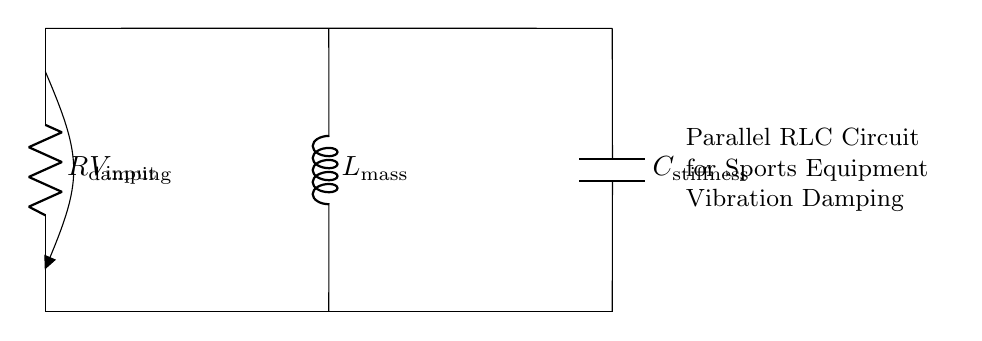What is the type of this circuit? This circuit is identified as a parallel RLC circuit due to its arrangement of a resistor, an inductor, and a capacitor connected in parallel configuration.
Answer: parallel RLC circuit What components are present in the circuit? The components present in the circuit are a resistor, an inductor, and a capacitor. This can be identified from the labels R, L, and C in the circuit diagram.
Answer: resistor, inductor, capacitor What is the purpose of the resistor in this circuit? The purpose of the resistor in this circuit is to provide damping. This is indicated by its label R_damping, which suggests it's specifically meant to reduce oscillations caused by the inductor and capacitor.
Answer: damping What is the role of the capacitor in this setup? The role of the capacitor in this setup is to store energy and provide stiffness. It is labeled C_stiffness, indicating that it helps in managing the stiffness of the vibration system.
Answer: stiffness If the resistance is increased, what happens to the damping? If the resistance is increased, the damping effect will also increase. This is because higher resistance causes more energy dissipation, leading to less oscillation and better vibration control in the system.
Answer: increases What is the voltage source labeled as in this circuit? The voltage source is labeled as V_input, which is the voltage applied to the circuit to drive the current through the components.
Answer: V_input What happens to the overall impedance of the circuit as frequency changes? As frequency changes, the impedance of the parallel RLC circuit also changes. At resonance, the impedance is at a minimum due to the interplay between the resistor, inductor, and capacitor. This impacts how the circuit responds to vibrations.
Answer: changes 